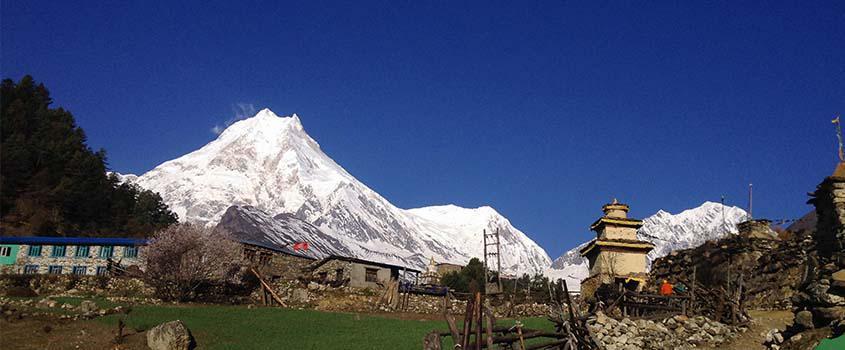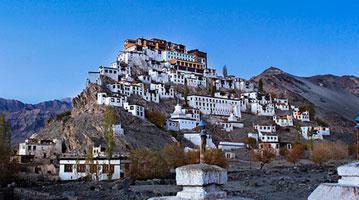The first image is the image on the left, the second image is the image on the right. Examine the images to the left and right. Is the description "An image shows a hillside covered with buildings with windows, and rustic white structures in the foreground." accurate? Answer yes or no. Yes. The first image is the image on the left, the second image is the image on the right. Assess this claim about the two images: "There are flags located on several buildings in one of the images.". Correct or not? Answer yes or no. No. 